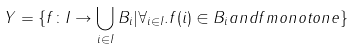Convert formula to latex. <formula><loc_0><loc_0><loc_500><loc_500>Y = \{ f \colon I \to \bigcup _ { i \in I } B _ { i } | \forall _ { i \in I } . f ( i ) \in B _ { i } a n d f m o n o t o n e \}</formula> 